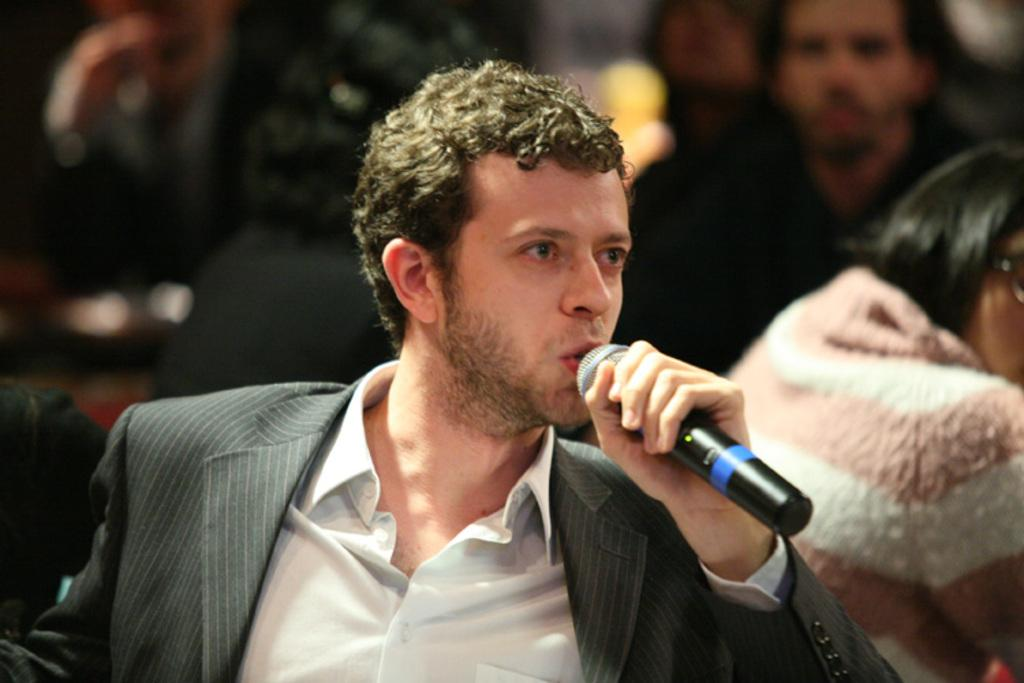How many people are present in the image? There are many people in the image. Can you identify any specific actions being performed by someone in the image? Yes, there is a person holding a mic in the image. What is the person holding the mic doing with it? The person holding the mic is speaking into it. What type of quilt is being used to cover the person holding the mic in the image? There is no quilt present in the image, and the person holding the mic is not covered by any such item. What type of skin condition can be seen on the person holding the mic in the image? There is no indication of any skin condition on the person holding the mic in the image. 